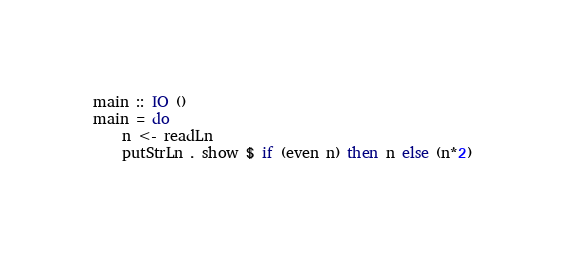<code> <loc_0><loc_0><loc_500><loc_500><_Haskell_>main :: IO ()
main = do
    n <- readLn
    putStrLn . show $ if (even n) then n else (n*2)
</code> 